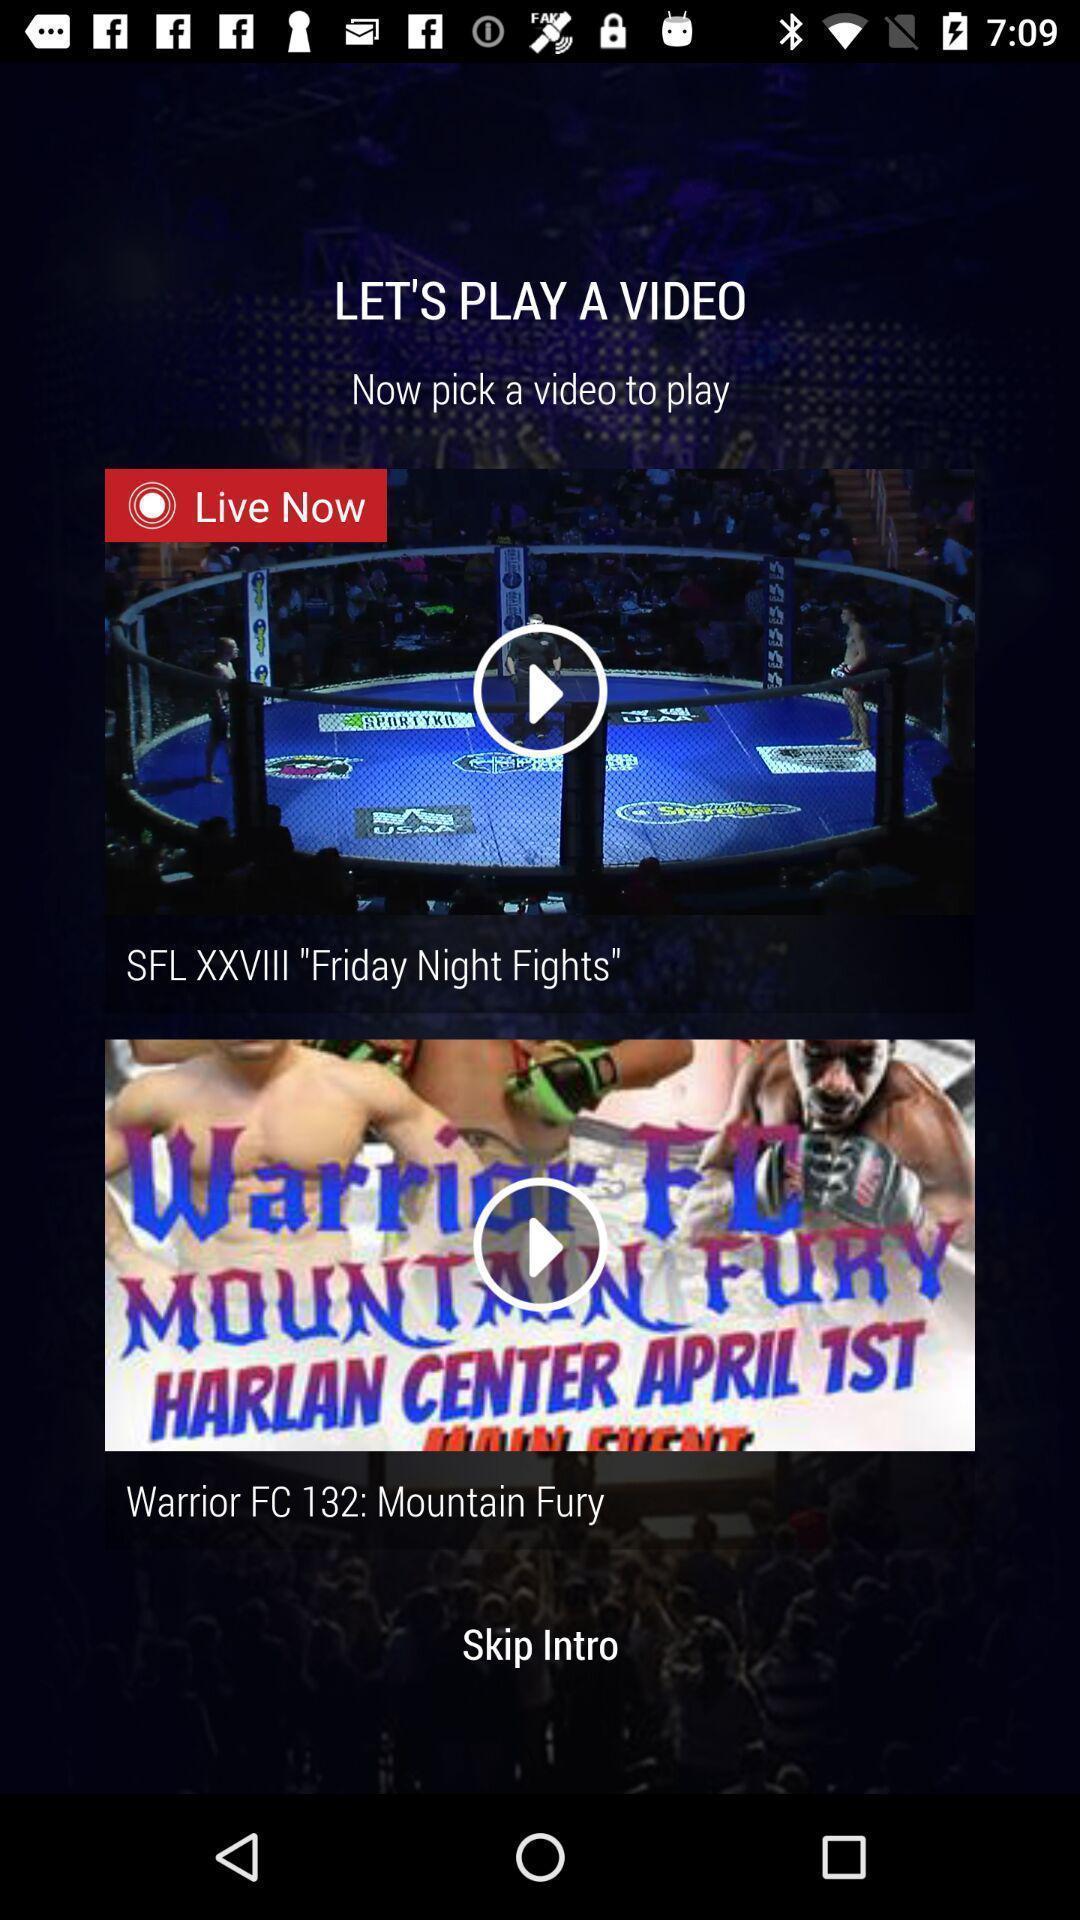Provide a description of this screenshot. Screen showing live now video. 